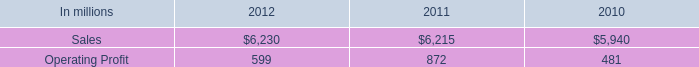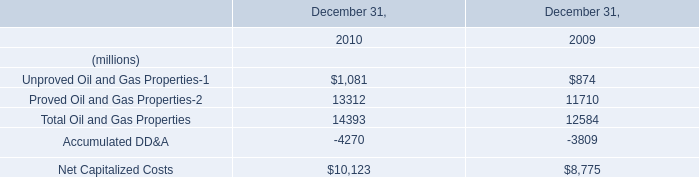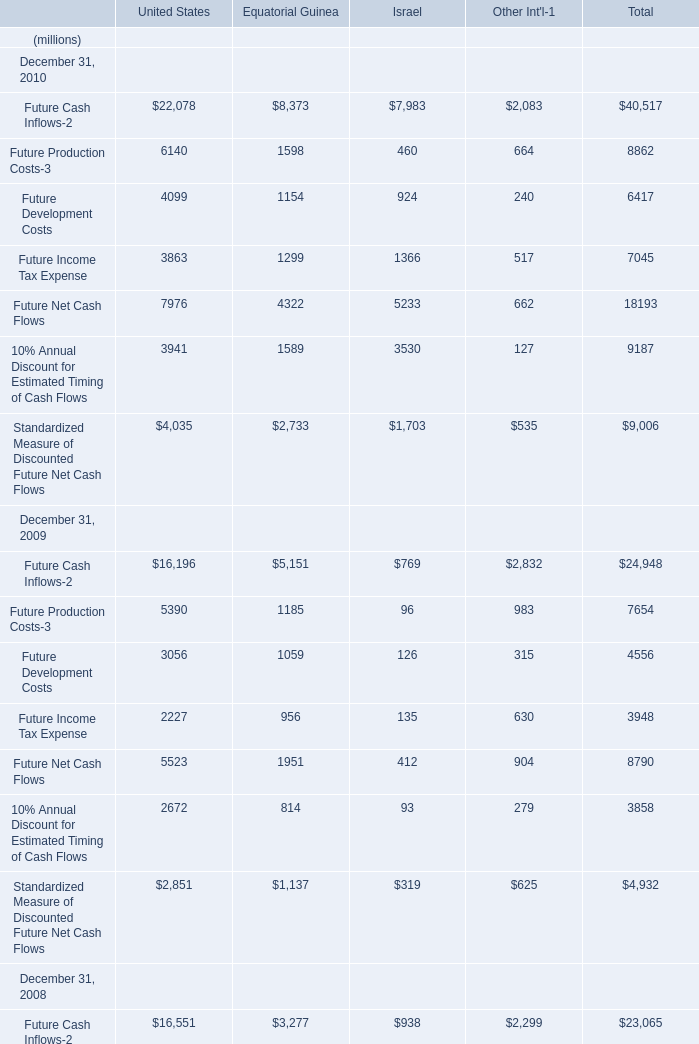In the year with the most Future Cash Inflows-2, what is the growth rate of Future Production Costs-3? 
Computations: ((8862 - 7654) / 8862)
Answer: 0.13631. 